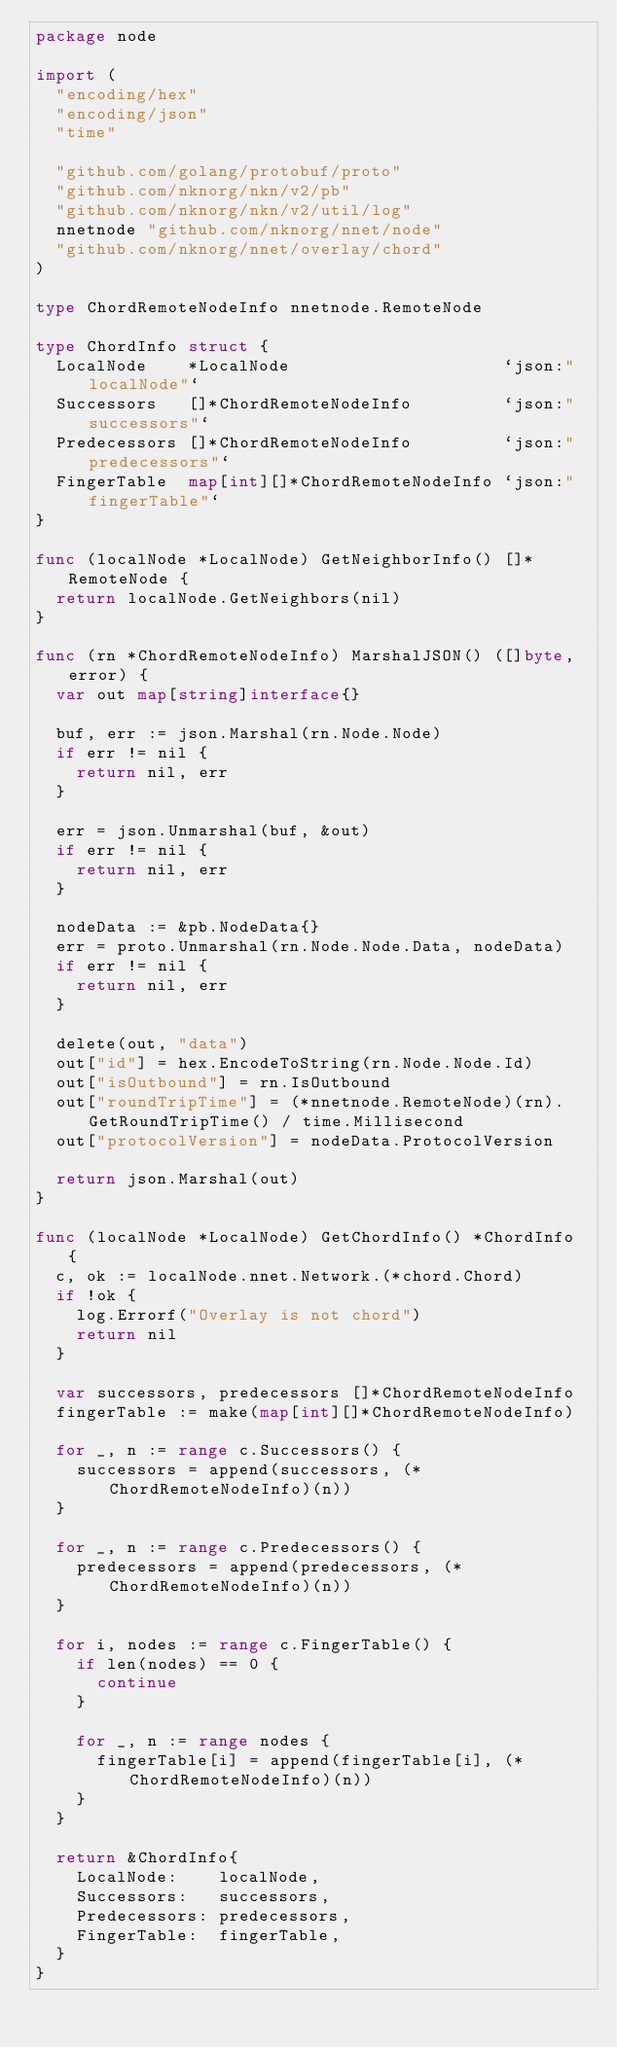Convert code to text. <code><loc_0><loc_0><loc_500><loc_500><_Go_>package node

import (
	"encoding/hex"
	"encoding/json"
	"time"

	"github.com/golang/protobuf/proto"
	"github.com/nknorg/nkn/v2/pb"
	"github.com/nknorg/nkn/v2/util/log"
	nnetnode "github.com/nknorg/nnet/node"
	"github.com/nknorg/nnet/overlay/chord"
)

type ChordRemoteNodeInfo nnetnode.RemoteNode

type ChordInfo struct {
	LocalNode    *LocalNode                     `json:"localNode"`
	Successors   []*ChordRemoteNodeInfo         `json:"successors"`
	Predecessors []*ChordRemoteNodeInfo         `json:"predecessors"`
	FingerTable  map[int][]*ChordRemoteNodeInfo `json:"fingerTable"`
}

func (localNode *LocalNode) GetNeighborInfo() []*RemoteNode {
	return localNode.GetNeighbors(nil)
}

func (rn *ChordRemoteNodeInfo) MarshalJSON() ([]byte, error) {
	var out map[string]interface{}

	buf, err := json.Marshal(rn.Node.Node)
	if err != nil {
		return nil, err
	}

	err = json.Unmarshal(buf, &out)
	if err != nil {
		return nil, err
	}

	nodeData := &pb.NodeData{}
	err = proto.Unmarshal(rn.Node.Node.Data, nodeData)
	if err != nil {
		return nil, err
	}

	delete(out, "data")
	out["id"] = hex.EncodeToString(rn.Node.Node.Id)
	out["isOutbound"] = rn.IsOutbound
	out["roundTripTime"] = (*nnetnode.RemoteNode)(rn).GetRoundTripTime() / time.Millisecond
	out["protocolVersion"] = nodeData.ProtocolVersion

	return json.Marshal(out)
}

func (localNode *LocalNode) GetChordInfo() *ChordInfo {
	c, ok := localNode.nnet.Network.(*chord.Chord)
	if !ok {
		log.Errorf("Overlay is not chord")
		return nil
	}

	var successors, predecessors []*ChordRemoteNodeInfo
	fingerTable := make(map[int][]*ChordRemoteNodeInfo)

	for _, n := range c.Successors() {
		successors = append(successors, (*ChordRemoteNodeInfo)(n))
	}

	for _, n := range c.Predecessors() {
		predecessors = append(predecessors, (*ChordRemoteNodeInfo)(n))
	}

	for i, nodes := range c.FingerTable() {
		if len(nodes) == 0 {
			continue
		}

		for _, n := range nodes {
			fingerTable[i] = append(fingerTable[i], (*ChordRemoteNodeInfo)(n))
		}
	}

	return &ChordInfo{
		LocalNode:    localNode,
		Successors:   successors,
		Predecessors: predecessors,
		FingerTable:  fingerTable,
	}
}
</code> 